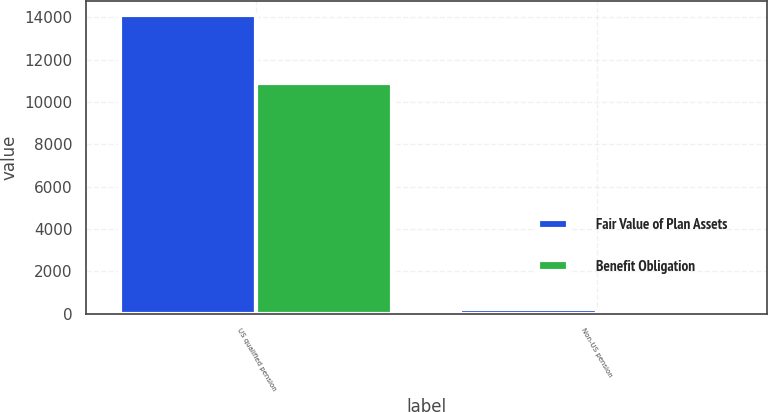Convert chart. <chart><loc_0><loc_0><loc_500><loc_500><stacked_bar_chart><ecel><fcel>US qualified pension<fcel>Non-US pension<nl><fcel>Fair Value of Plan Assets<fcel>14092<fcel>204<nl><fcel>Benefit Obligation<fcel>10923<fcel>155<nl></chart> 